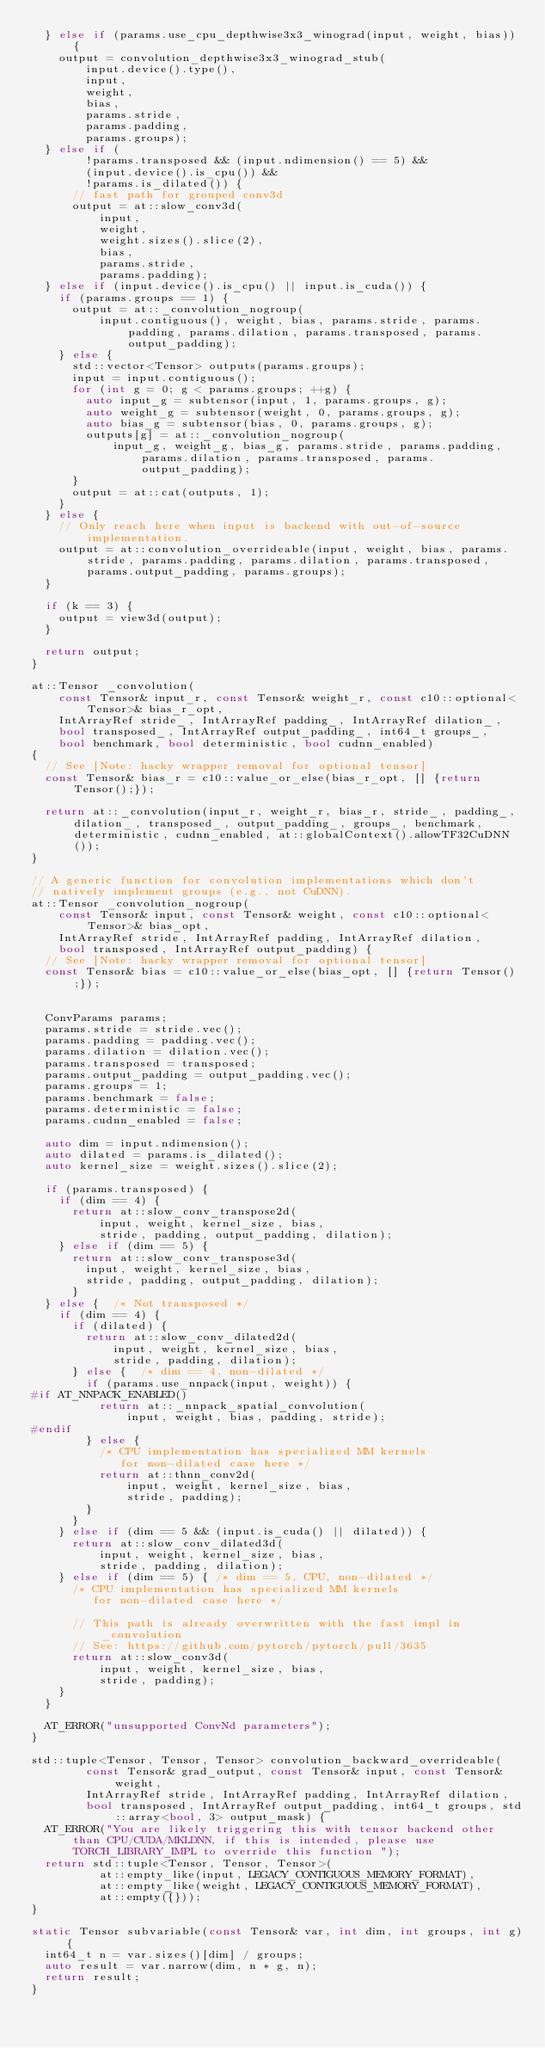Convert code to text. <code><loc_0><loc_0><loc_500><loc_500><_C++_>  } else if (params.use_cpu_depthwise3x3_winograd(input, weight, bias)) {
    output = convolution_depthwise3x3_winograd_stub(
        input.device().type(),
        input,
        weight,
        bias,
        params.stride,
        params.padding,
        params.groups);
  } else if (
        !params.transposed && (input.ndimension() == 5) &&
        (input.device().is_cpu()) &&
        !params.is_dilated()) {
      // fast path for grouped conv3d
      output = at::slow_conv3d(
          input,
          weight,
          weight.sizes().slice(2),
          bias,
          params.stride,
          params.padding);
  } else if (input.device().is_cpu() || input.is_cuda()) {
    if (params.groups == 1) {
      output = at::_convolution_nogroup(
          input.contiguous(), weight, bias, params.stride, params.padding, params.dilation, params.transposed, params.output_padding);
    } else {
      std::vector<Tensor> outputs(params.groups);
      input = input.contiguous();
      for (int g = 0; g < params.groups; ++g) {
        auto input_g = subtensor(input, 1, params.groups, g);
        auto weight_g = subtensor(weight, 0, params.groups, g);
        auto bias_g = subtensor(bias, 0, params.groups, g);
        outputs[g] = at::_convolution_nogroup(
            input_g, weight_g, bias_g, params.stride, params.padding, params.dilation, params.transposed, params.output_padding);
      }
      output = at::cat(outputs, 1);
    }
  } else {
    // Only reach here when input is backend with out-of-source implementation.
    output = at::convolution_overrideable(input, weight, bias, params.stride, params.padding, params.dilation, params.transposed, params.output_padding, params.groups);
  }

  if (k == 3) {
    output = view3d(output);
  }

  return output;
}

at::Tensor _convolution(
    const Tensor& input_r, const Tensor& weight_r, const c10::optional<Tensor>& bias_r_opt,
    IntArrayRef stride_, IntArrayRef padding_, IntArrayRef dilation_,
    bool transposed_, IntArrayRef output_padding_, int64_t groups_,
    bool benchmark, bool deterministic, bool cudnn_enabled)
{
  // See [Note: hacky wrapper removal for optional tensor]
  const Tensor& bias_r = c10::value_or_else(bias_r_opt, [] {return Tensor();});

  return at::_convolution(input_r, weight_r, bias_r, stride_, padding_, dilation_, transposed_, output_padding_, groups_, benchmark, deterministic, cudnn_enabled, at::globalContext().allowTF32CuDNN());
}

// A generic function for convolution implementations which don't
// natively implement groups (e.g., not CuDNN).
at::Tensor _convolution_nogroup(
    const Tensor& input, const Tensor& weight, const c10::optional<Tensor>& bias_opt,
    IntArrayRef stride, IntArrayRef padding, IntArrayRef dilation,
    bool transposed, IntArrayRef output_padding) {
  // See [Note: hacky wrapper removal for optional tensor]
  const Tensor& bias = c10::value_or_else(bias_opt, [] {return Tensor();});


  ConvParams params;
  params.stride = stride.vec();
  params.padding = padding.vec();
  params.dilation = dilation.vec();
  params.transposed = transposed;
  params.output_padding = output_padding.vec();
  params.groups = 1;
  params.benchmark = false;
  params.deterministic = false;
  params.cudnn_enabled = false;

  auto dim = input.ndimension();
  auto dilated = params.is_dilated();
  auto kernel_size = weight.sizes().slice(2);

  if (params.transposed) {
    if (dim == 4) {
      return at::slow_conv_transpose2d(
          input, weight, kernel_size, bias,
          stride, padding, output_padding, dilation);
    } else if (dim == 5) {
      return at::slow_conv_transpose3d(
        input, weight, kernel_size, bias,
        stride, padding, output_padding, dilation);
      }
  } else {  /* Not transposed */
    if (dim == 4) {
      if (dilated) {
        return at::slow_conv_dilated2d(
            input, weight, kernel_size, bias,
            stride, padding, dilation);
      } else {  /* dim == 4, non-dilated */
        if (params.use_nnpack(input, weight)) {
#if AT_NNPACK_ENABLED()
          return at::_nnpack_spatial_convolution(
              input, weight, bias, padding, stride);
#endif
        } else {
          /* CPU implementation has specialized MM kernels
             for non-dilated case here */
          return at::thnn_conv2d(
              input, weight, kernel_size, bias,
              stride, padding);
        }
      }
    } else if (dim == 5 && (input.is_cuda() || dilated)) {
      return at::slow_conv_dilated3d(
          input, weight, kernel_size, bias,
          stride, padding, dilation);
    } else if (dim == 5) { /* dim == 5, CPU, non-dilated */
      /* CPU implementation has specialized MM kernels
         for non-dilated case here */

      // This path is already overwritten with the fast impl in _convolution
      // See: https://github.com/pytorch/pytorch/pull/3635
      return at::slow_conv3d(
          input, weight, kernel_size, bias,
          stride, padding);
    }
  }

  AT_ERROR("unsupported ConvNd parameters");
}

std::tuple<Tensor, Tensor, Tensor> convolution_backward_overrideable(
        const Tensor& grad_output, const Tensor& input, const Tensor& weight,
        IntArrayRef stride, IntArrayRef padding, IntArrayRef dilation,
        bool transposed, IntArrayRef output_padding, int64_t groups, std::array<bool, 3> output_mask) {
  AT_ERROR("You are likely triggering this with tensor backend other than CPU/CUDA/MKLDNN, if this is intended, please use TORCH_LIBRARY_IMPL to override this function ");
  return std::tuple<Tensor, Tensor, Tensor>(
          at::empty_like(input, LEGACY_CONTIGUOUS_MEMORY_FORMAT),
          at::empty_like(weight, LEGACY_CONTIGUOUS_MEMORY_FORMAT),
          at::empty({}));
}

static Tensor subvariable(const Tensor& var, int dim, int groups, int g) {
  int64_t n = var.sizes()[dim] / groups;
  auto result = var.narrow(dim, n * g, n);
  return result;
}
</code> 